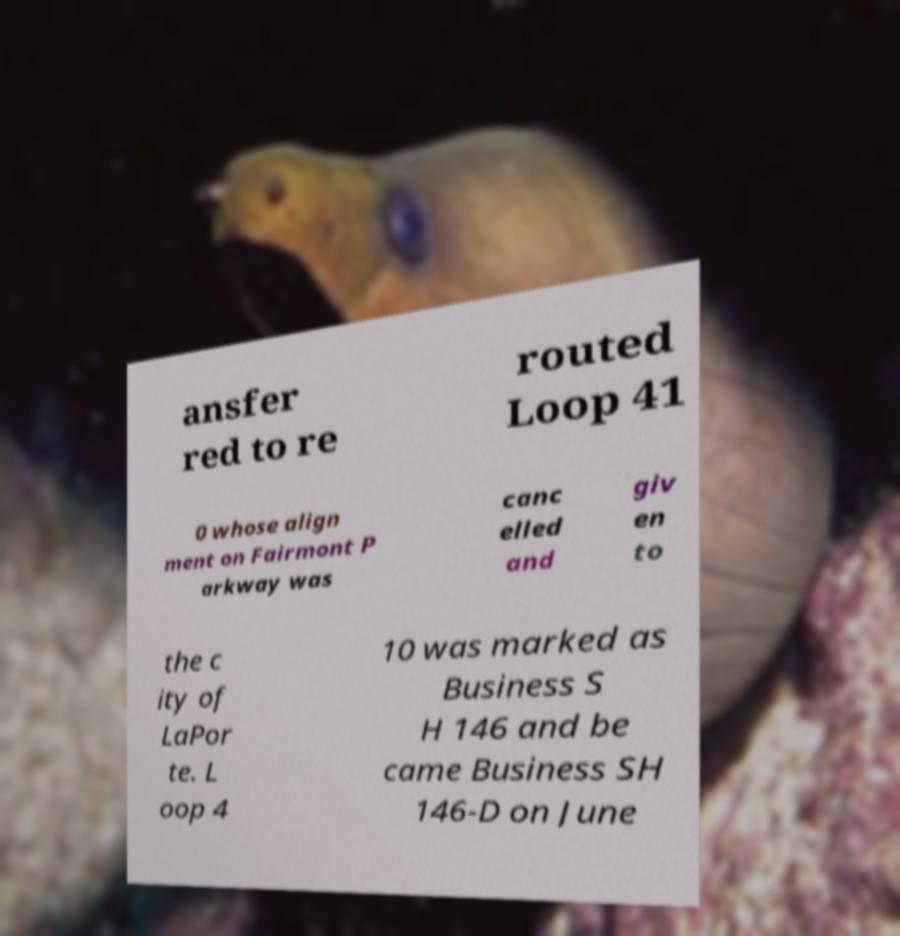What messages or text are displayed in this image? I need them in a readable, typed format. ansfer red to re routed Loop 41 0 whose align ment on Fairmont P arkway was canc elled and giv en to the c ity of LaPor te. L oop 4 10 was marked as Business S H 146 and be came Business SH 146-D on June 